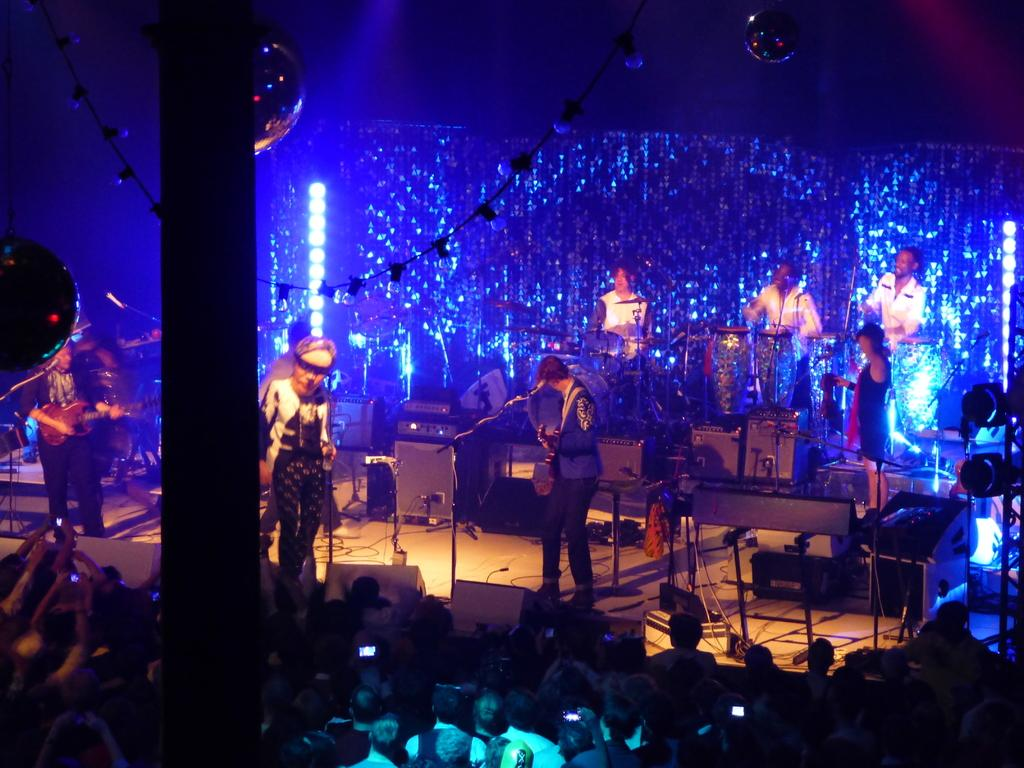What are the people on the stage doing? The people on the stage are playing musical instruments. Who is watching the people on the stage? There are spectators watching the people on the stage. Can you describe the setting of the image? The setting of the image is a stage where people are performing. What type of robin can be seen singing on the stage in the image? There is no robin present in the image; it features people playing musical instruments on a stage. 